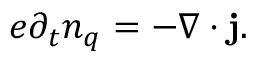<formula> <loc_0><loc_0><loc_500><loc_500>e \partial _ { t } n _ { q } = - \nabla \cdot { j } .</formula> 